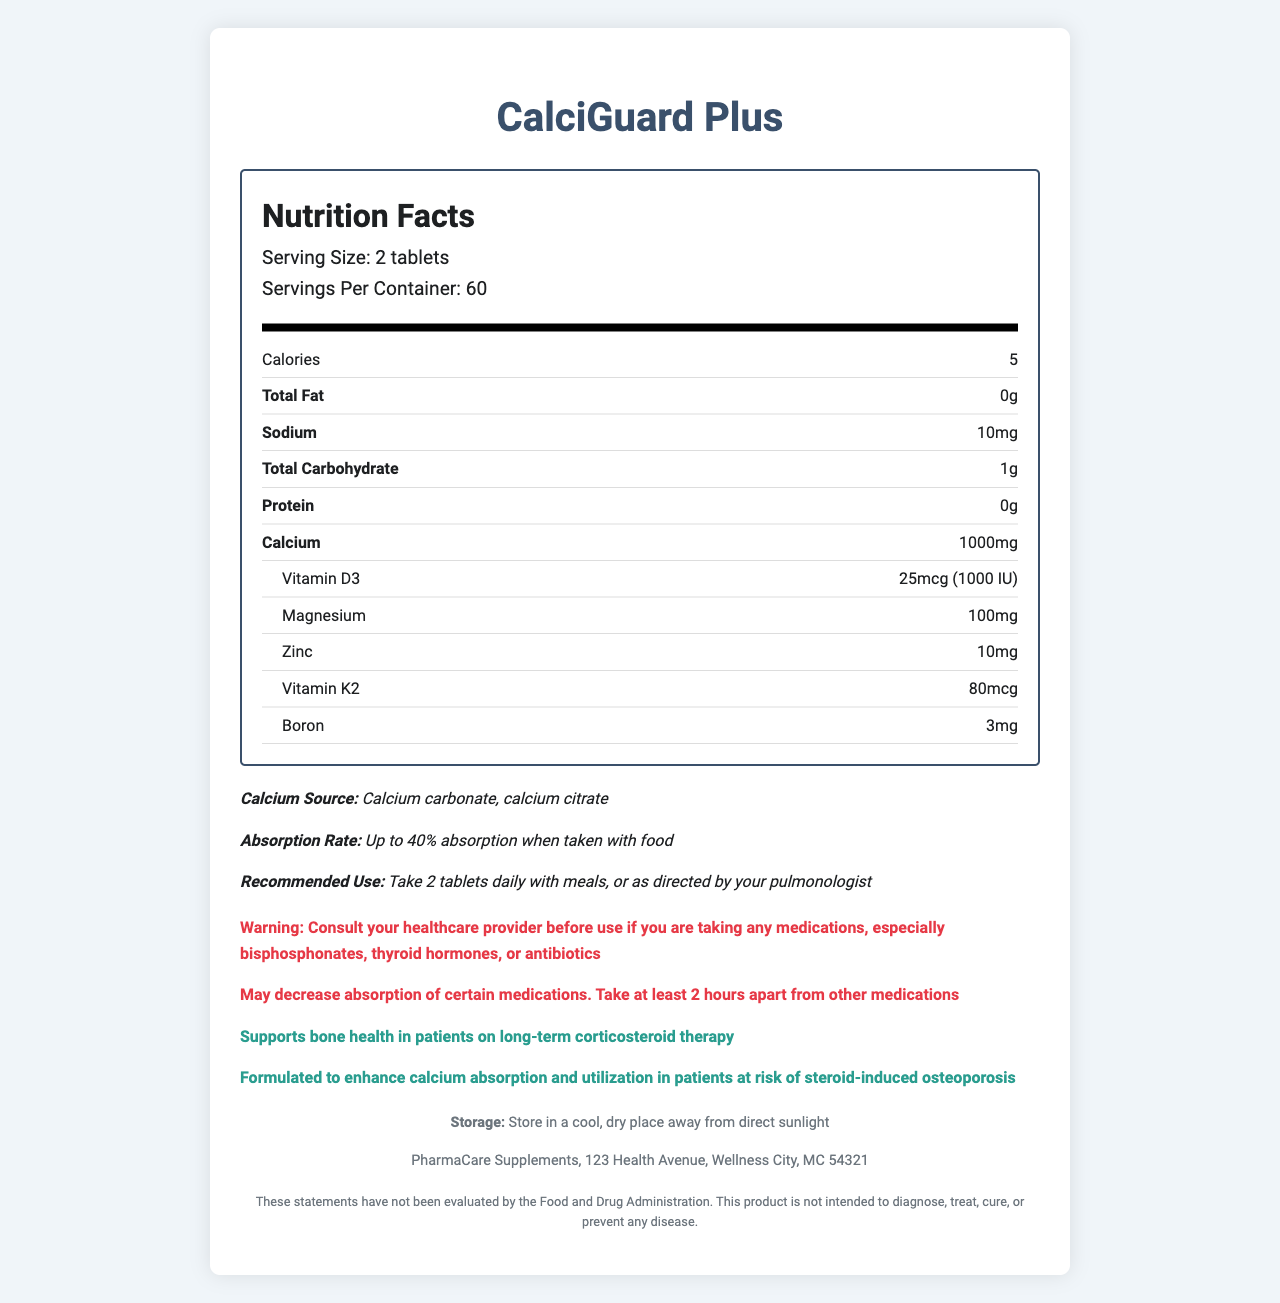what is the serving size? The document states that the serving size is 2 tablets.
Answer: 2 tablets what is the amount of calcium per serving? The document lists that there are 1000 mg of calcium per serving.
Answer: 1000 mg how many servings are in one container? The document shows that there are 60 servings per container.
Answer: 60 what is the total carbohydrate content per serving? The total carbohydrate content per serving is listed as 1 g in the document.
Answer: 1 g what is the recommended daily intake of calcium for someone taking this supplement? The recommended use section in the document advises to take 2 tablets daily.
Answer: 2 tablets What ingredients enhance calcium absorption and utilization? A. Calcium carbonate and calcium citrate B. Vitamin D3 and boron C. Magnesium and zinc D. All of the above The document lists calcium carbonate, calcium citrate (both calcium sources), as well as vitamin D3, magnesium, zinc, vitamin K2, and boron, which are all mentioned to enhance calcium absorption and utilization.
Answer: D Which of the following medications could interact with this supplement? I. Bisphosphonates II. Thyroid hormones III. Antibiotics The warning statement in the document advises to consult a healthcare provider if taking bisphosphonates, thyroid hormones, or antibiotics because of possible interactions.
Answer: I, II, and III Is it necessary to take this supplement with food? The document mentions that the absorption rate is up to 40% when taken with food and recommends taking the tablets with meals.
Answer: Yes can you determine the exact cost of the CalciGuard Plus supplement from this label? The document does not provide any information regarding the price of the supplement.
Answer: Not enough information summarize the main benefits and cautions of CalciGuard Plus based on the document The main idea comes from the listed nutrients and their benefits, the absorption rates when taken with food, and the interaction warnings that need to be considered.
Answer: CalciGuard Plus supports bone health for patients on long-term corticosteroid therapy by providing essential nutrients like calcium, vitamin D3, and magnesium. It should be taken with meals to maximize absorption. There are warnings about potential interactions with bisphosphonates, thyroid hormones, and antibiotics, advising a two-hour gap between taking this supplement and other medications. 